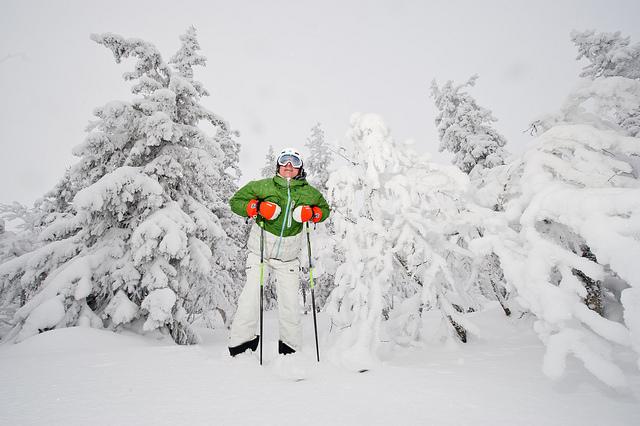What color is her coat?
Quick response, please. Green. What is the green round object in the background?
Concise answer only. Jacket. What is the person surrounded by?
Keep it brief. Snow. Are his gloves orange?
Write a very short answer. Yes. Is the snow up to the man's waist?
Write a very short answer. No. Does this person have pants on?
Keep it brief. Yes. 